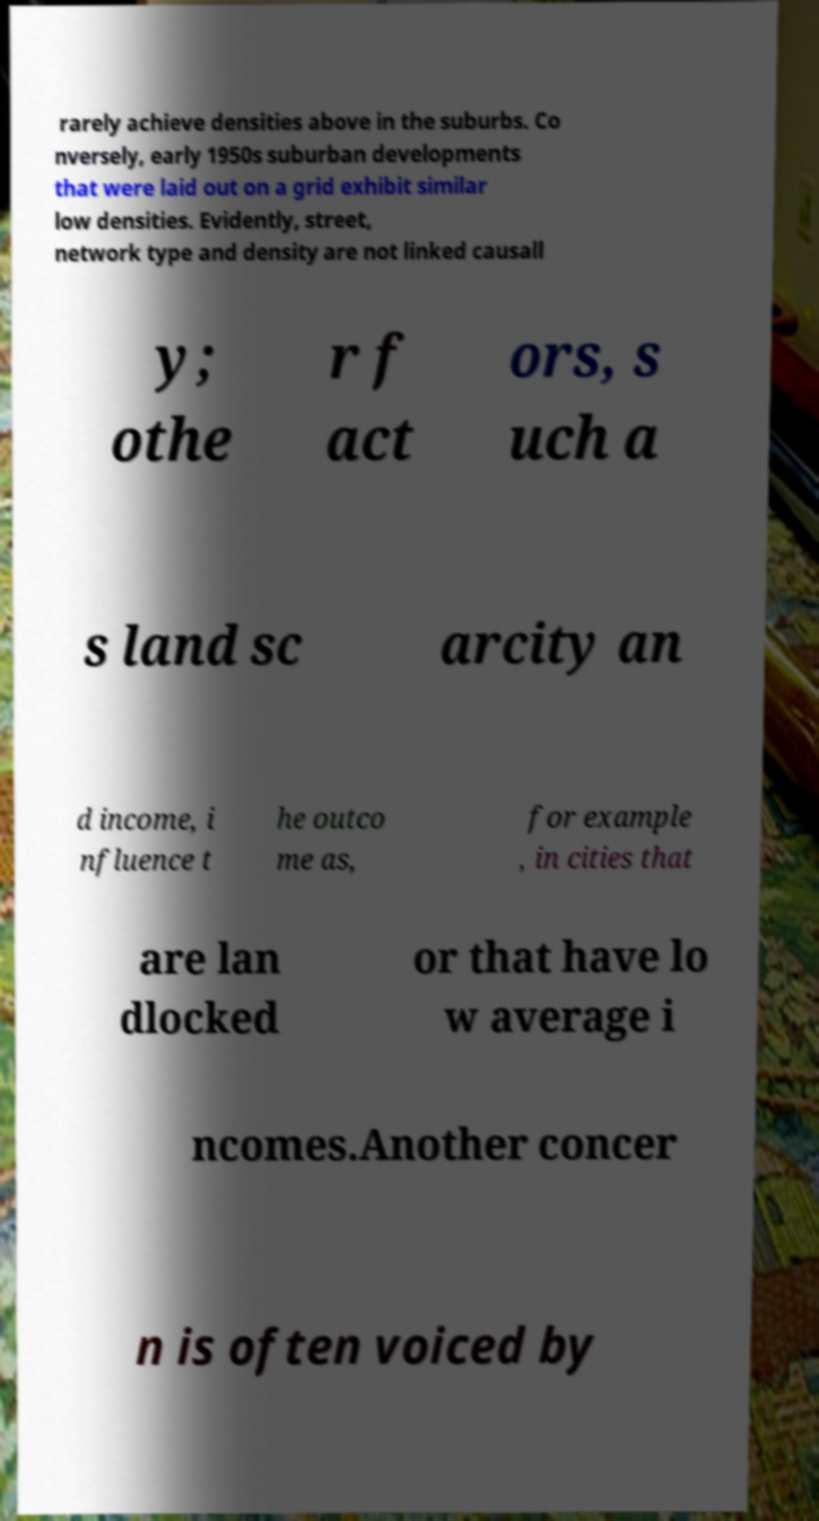Can you read and provide the text displayed in the image?This photo seems to have some interesting text. Can you extract and type it out for me? rarely achieve densities above in the suburbs. Co nversely, early 1950s suburban developments that were laid out on a grid exhibit similar low densities. Evidently, street, network type and density are not linked causall y; othe r f act ors, s uch a s land sc arcity an d income, i nfluence t he outco me as, for example , in cities that are lan dlocked or that have lo w average i ncomes.Another concer n is often voiced by 